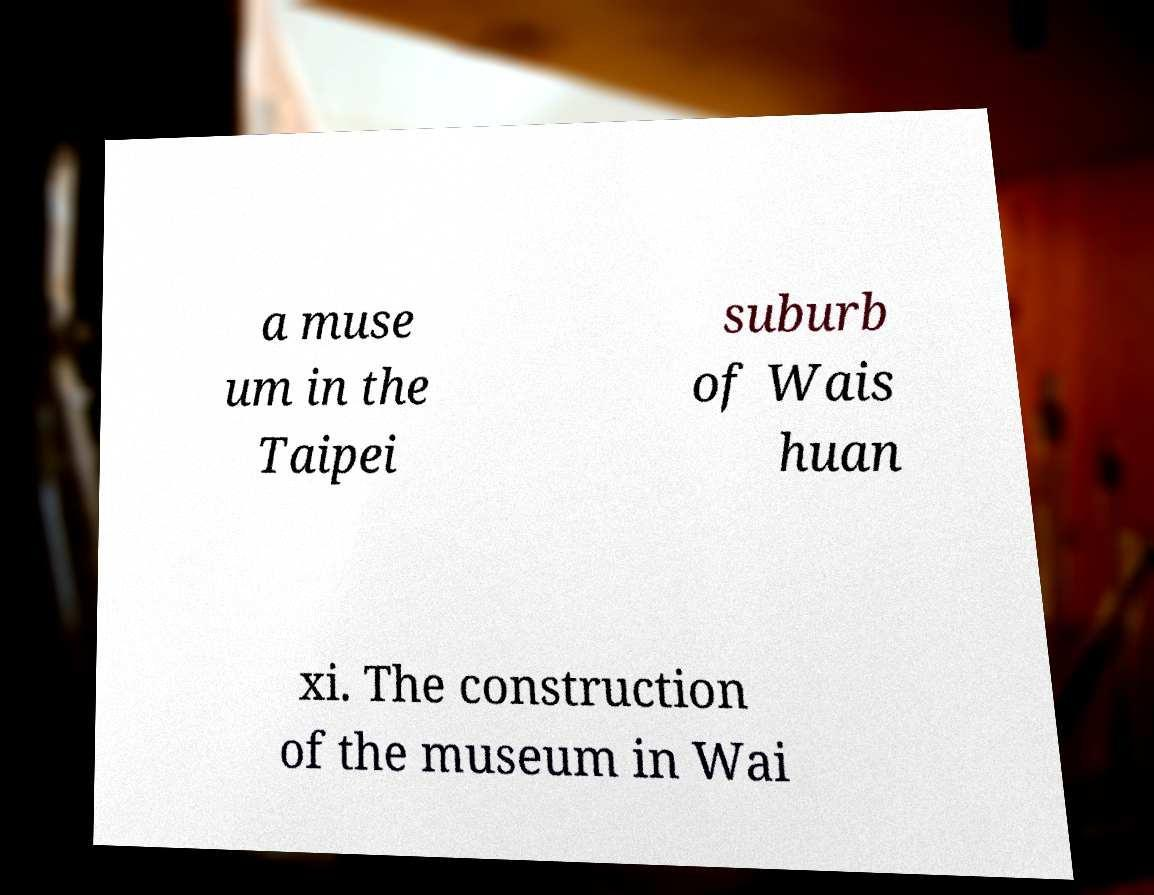Could you extract and type out the text from this image? a muse um in the Taipei suburb of Wais huan xi. The construction of the museum in Wai 